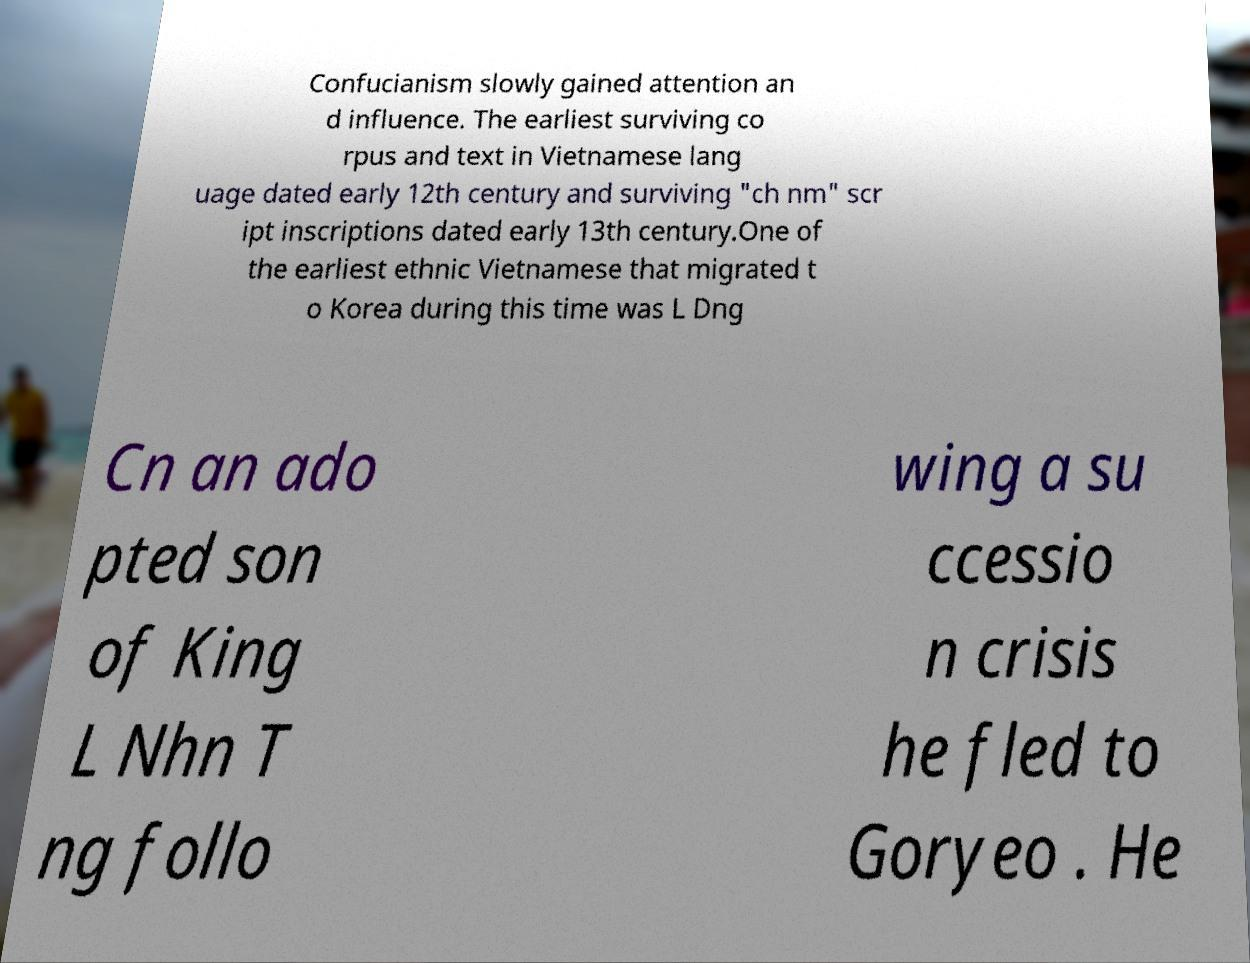Could you assist in decoding the text presented in this image and type it out clearly? Confucianism slowly gained attention an d influence. The earliest surviving co rpus and text in Vietnamese lang uage dated early 12th century and surviving "ch nm" scr ipt inscriptions dated early 13th century.One of the earliest ethnic Vietnamese that migrated t o Korea during this time was L Dng Cn an ado pted son of King L Nhn T ng follo wing a su ccessio n crisis he fled to Goryeo . He 